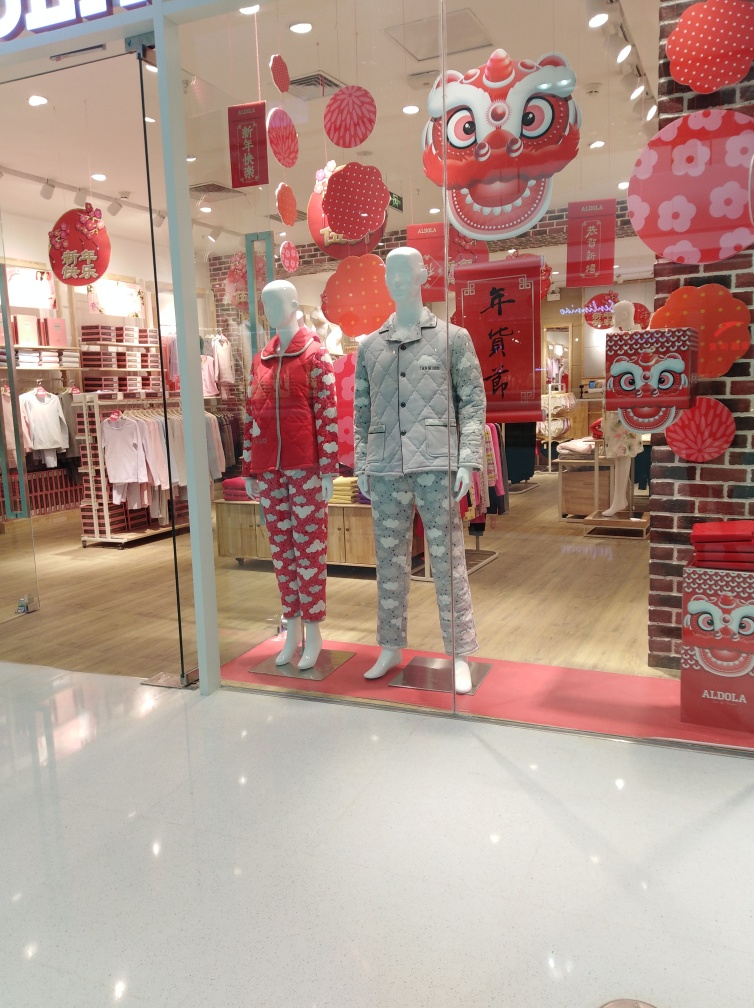How would you describe the composition of the image? The image portrays a storefront with a festive theme, presumably for a cultural celebration given the traditional red lanterns and ornamental spheres. Two mannequins are positioned in the foreground, one dressed in vibrant red with patterned hearts and the other in a subdued blue with snowflake designs. The decorations suggest the celebration might be the Chinese Lunar New Year, indicated by the use of red - a color symbolizing good fortune in Chinese culture. 